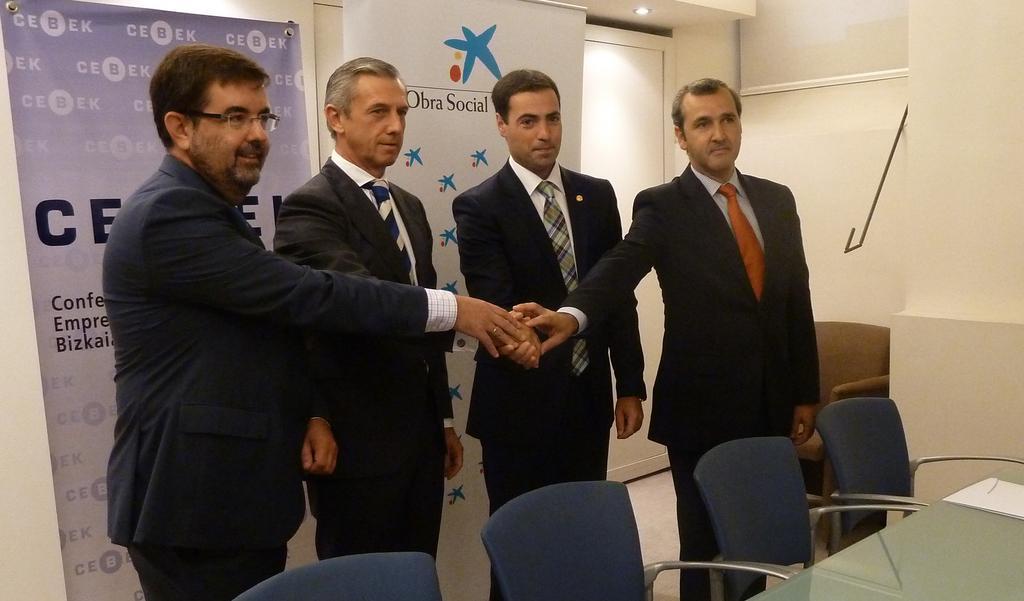In one or two sentences, can you explain what this image depicts? In this image I can see four men wearing suits, standing, shaking their hands and giving pose for the picture. In front of these people there are some empty chairs and a table. In the background there is a wall to which two posters are attached. On the posters I can see some text. 